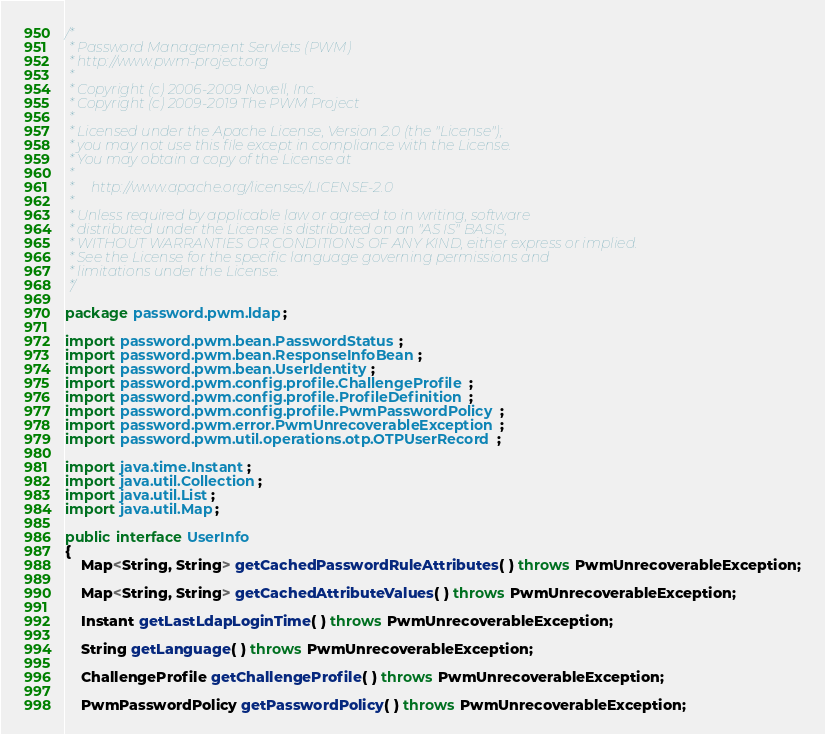Convert code to text. <code><loc_0><loc_0><loc_500><loc_500><_Java_>/*
 * Password Management Servlets (PWM)
 * http://www.pwm-project.org
 *
 * Copyright (c) 2006-2009 Novell, Inc.
 * Copyright (c) 2009-2019 The PWM Project
 *
 * Licensed under the Apache License, Version 2.0 (the "License");
 * you may not use this file except in compliance with the License.
 * You may obtain a copy of the License at
 *
 *     http://www.apache.org/licenses/LICENSE-2.0
 *
 * Unless required by applicable law or agreed to in writing, software
 * distributed under the License is distributed on an "AS IS" BASIS,
 * WITHOUT WARRANTIES OR CONDITIONS OF ANY KIND, either express or implied.
 * See the License for the specific language governing permissions and
 * limitations under the License.
 */

package password.pwm.ldap;

import password.pwm.bean.PasswordStatus;
import password.pwm.bean.ResponseInfoBean;
import password.pwm.bean.UserIdentity;
import password.pwm.config.profile.ChallengeProfile;
import password.pwm.config.profile.ProfileDefinition;
import password.pwm.config.profile.PwmPasswordPolicy;
import password.pwm.error.PwmUnrecoverableException;
import password.pwm.util.operations.otp.OTPUserRecord;

import java.time.Instant;
import java.util.Collection;
import java.util.List;
import java.util.Map;

public interface UserInfo
{
    Map<String, String> getCachedPasswordRuleAttributes( ) throws PwmUnrecoverableException;

    Map<String, String> getCachedAttributeValues( ) throws PwmUnrecoverableException;

    Instant getLastLdapLoginTime( ) throws PwmUnrecoverableException;

    String getLanguage( ) throws PwmUnrecoverableException;

    ChallengeProfile getChallengeProfile( ) throws PwmUnrecoverableException;

    PwmPasswordPolicy getPasswordPolicy( ) throws PwmUnrecoverableException;
</code> 